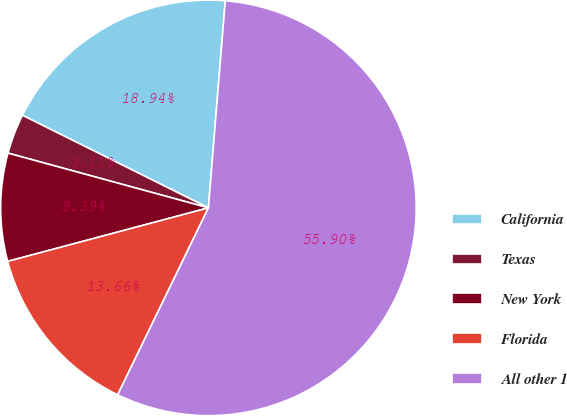Convert chart to OTSL. <chart><loc_0><loc_0><loc_500><loc_500><pie_chart><fcel>California<fcel>Texas<fcel>New York<fcel>Florida<fcel>All other 1<nl><fcel>18.94%<fcel>3.11%<fcel>8.39%<fcel>13.66%<fcel>55.9%<nl></chart> 